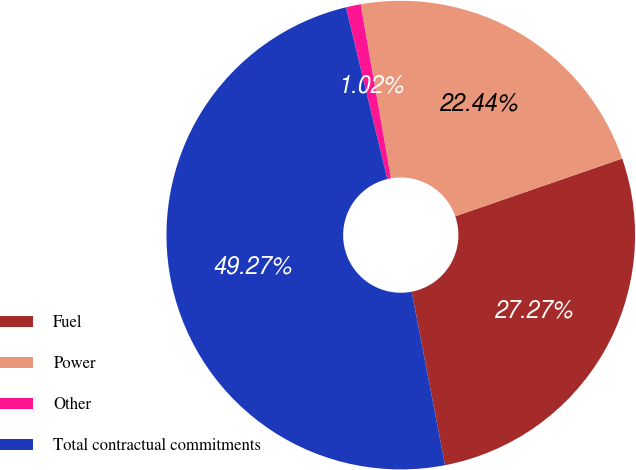<chart> <loc_0><loc_0><loc_500><loc_500><pie_chart><fcel>Fuel<fcel>Power<fcel>Other<fcel>Total contractual commitments<nl><fcel>27.27%<fcel>22.44%<fcel>1.02%<fcel>49.27%<nl></chart> 